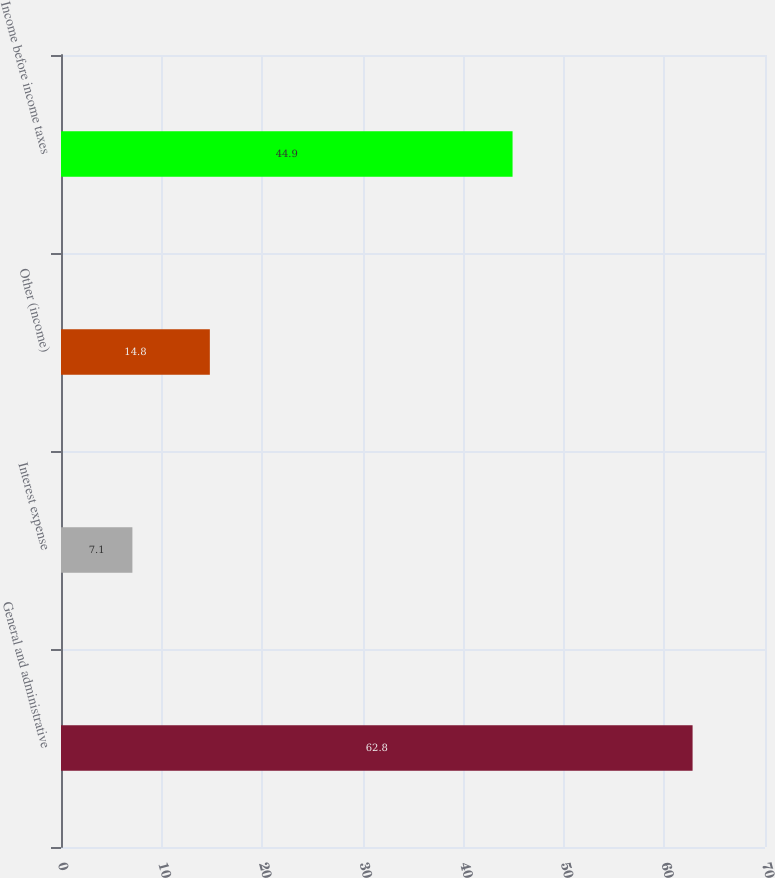Convert chart to OTSL. <chart><loc_0><loc_0><loc_500><loc_500><bar_chart><fcel>General and administrative<fcel>Interest expense<fcel>Other (income)<fcel>Income before income taxes<nl><fcel>62.8<fcel>7.1<fcel>14.8<fcel>44.9<nl></chart> 